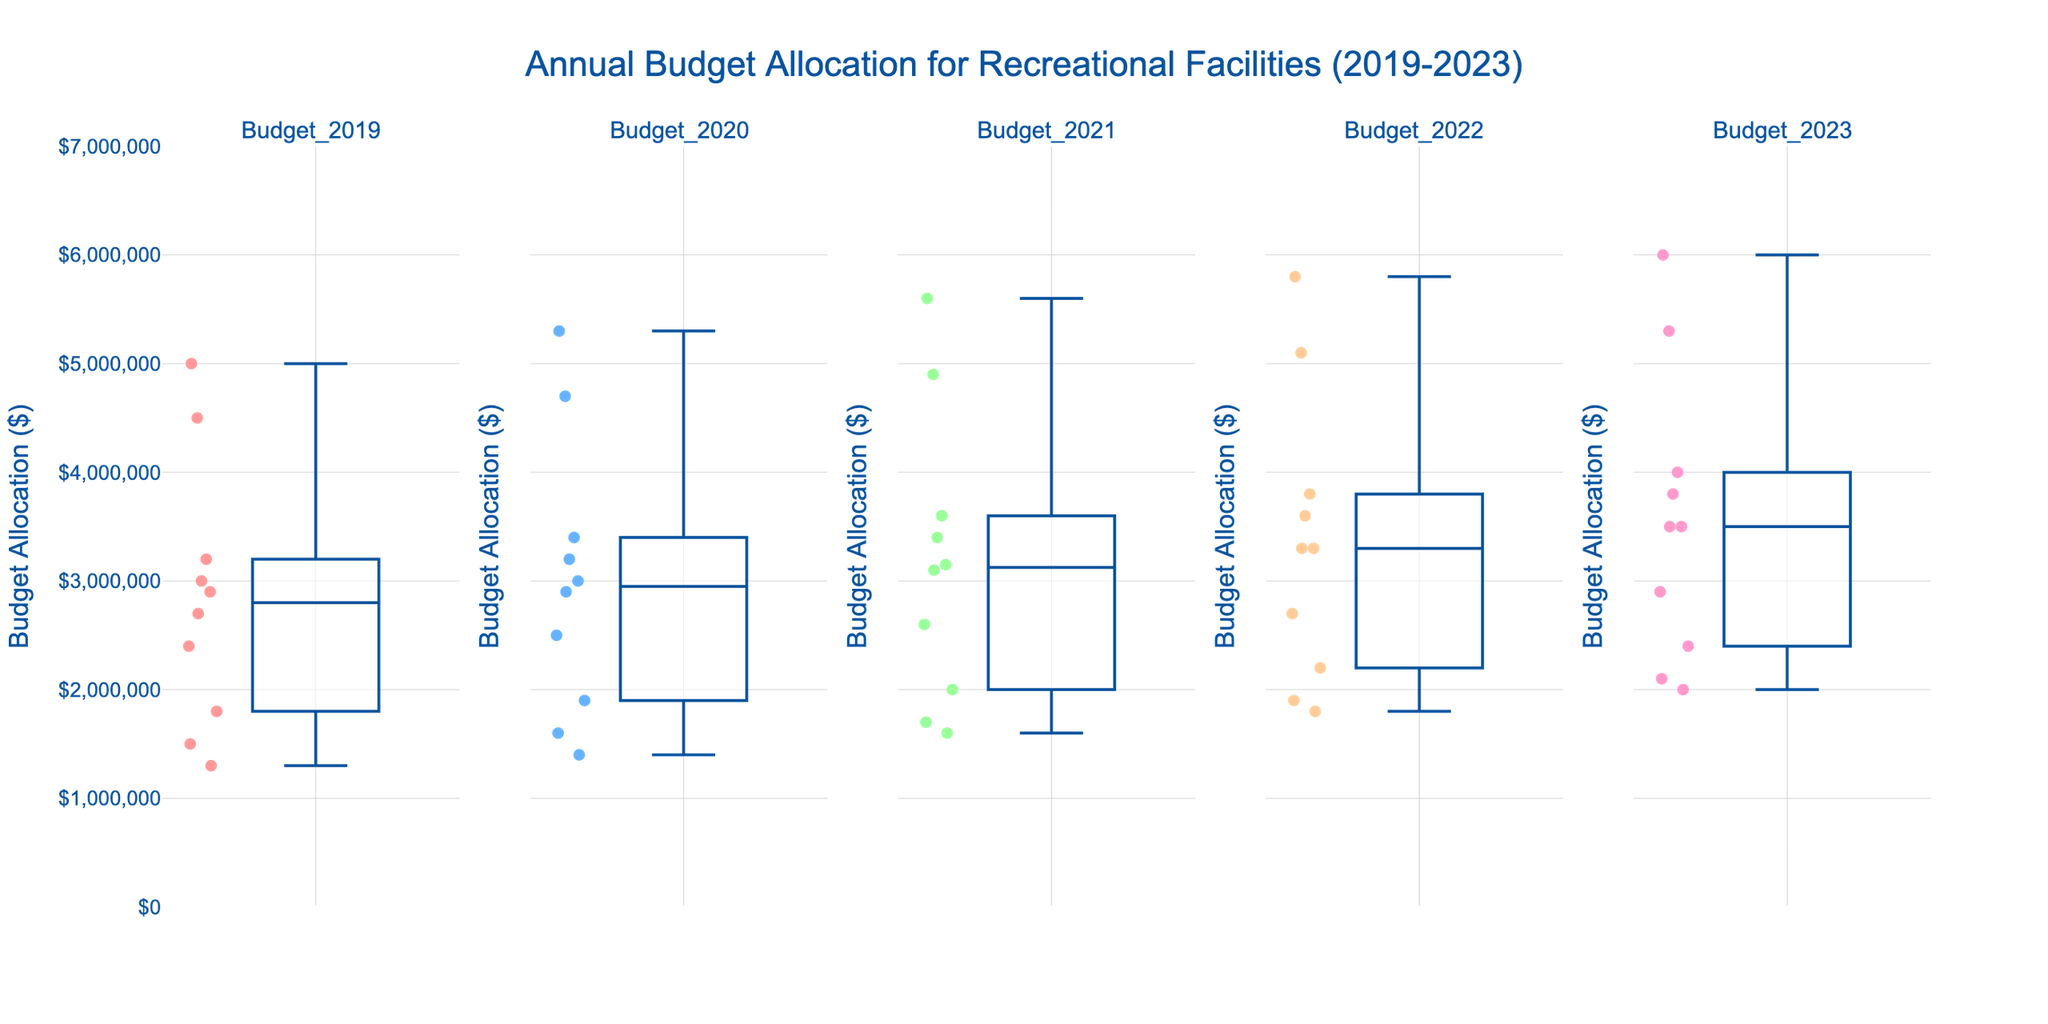What is the title of the figure? The title of the figure is clearly displayed at the top, center-aligned. It provides a summary of the data being represented.
Answer: Annual Budget Allocation for Recreational Facilities (2019-2023) Which city had the highest budget allocation in 2023? By observing the box plot for 2023, locate the city corresponding to the highest data point on the y-axis.
Answer: New York How has the budget allocation for Phoenix changed from 2019 to 2023? Track the position of Phoenix across the box plots for each year from 2019 to 2023. Observe the changes in the y-axis values.
Answer: Increased Which city shows the least variation in budget allocation over the years? Identify the city whose budget values have the smallest range or interquartile range across the plots from 2019 to 2023.
Answer: San Jose Compare the median budget allocation of New York and Los Angeles in 2022. Which city had a higher median? Identify the median lines (usually the middle line in the box) for New York and Los Angeles in the 2022 subplot. Compare these values.
Answer: New York What is the approximate budget allocation range for Chicago in 2021? Locate Chicago in the 2021 subplot, then identify the lower and upper bounds of the box and whiskers to determine the range.
Answer: $3,200,000 to $3,600,000 Which year had the highest median budget allocation across all cities? Compare the median lines in each subplot. The year with the highest median line has the highest median budget allocation.
Answer: 2023 By how much did the budget allocation for San Diego change from 2020 to 2022? Look at the budget for San Diego in 2020 and 2022 subplots. Calculate the difference between these two values.
Answer: $300,000 Is the budget allocation trend for San Antonio generally increasing, decreasing, or constant over the years? Observe the position of San Antonio in each subplot from 2019 to 2023. Note if the values are rising, falling, or staying the same.
Answer: Increasing 